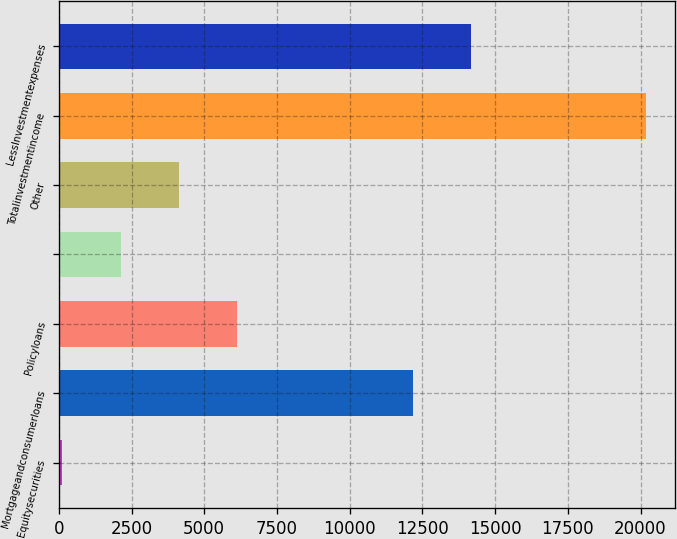Convert chart. <chart><loc_0><loc_0><loc_500><loc_500><bar_chart><fcel>Equitysecurities<fcel>Mortgageandconsumerloans<fcel>Policyloans<fcel>Unnamed: 3<fcel>Other<fcel>Totalinvestmentincome<fcel>LessInvestmentexpenses<nl><fcel>122<fcel>12162.8<fcel>6142.4<fcel>2128.8<fcel>4135.6<fcel>20190<fcel>14169.6<nl></chart> 